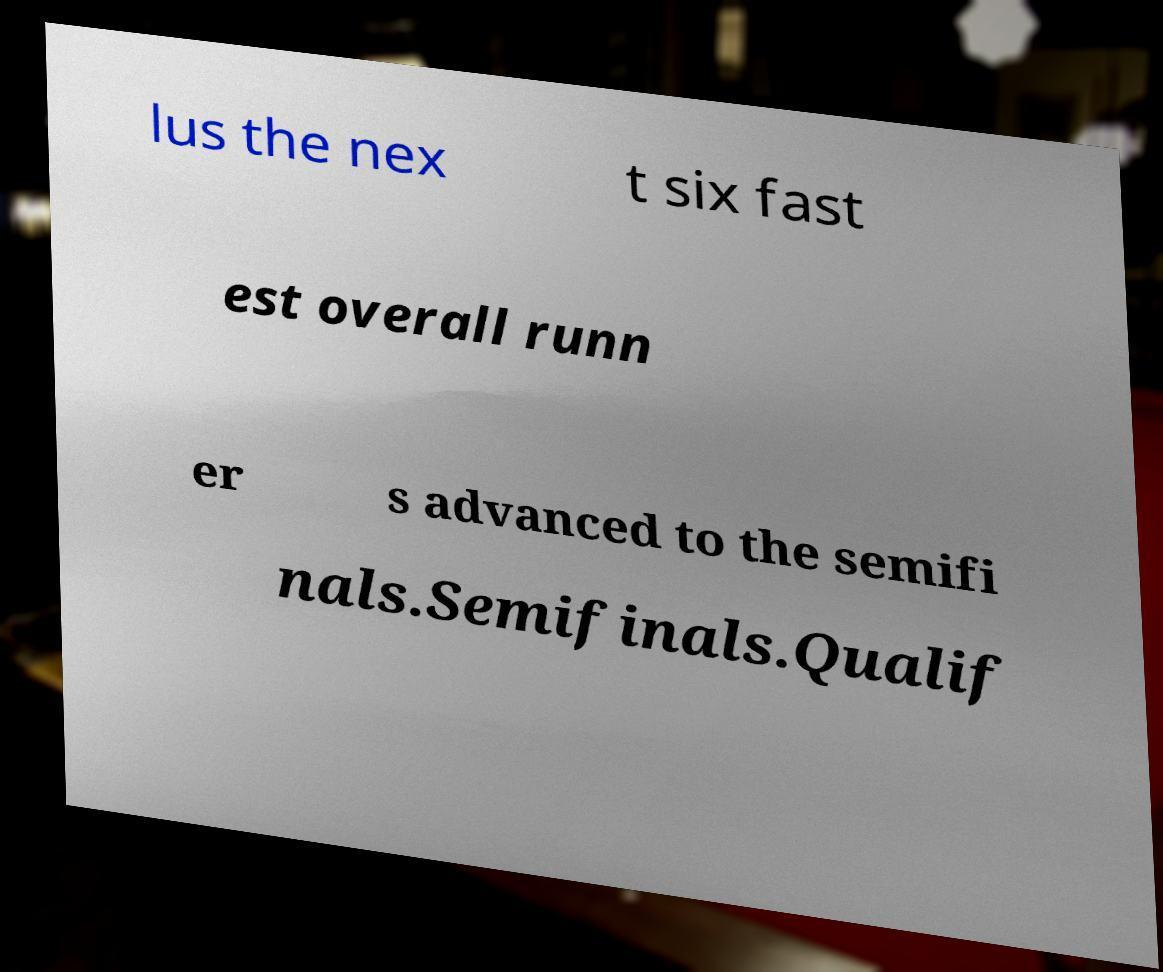Can you read and provide the text displayed in the image?This photo seems to have some interesting text. Can you extract and type it out for me? lus the nex t six fast est overall runn er s advanced to the semifi nals.Semifinals.Qualif 